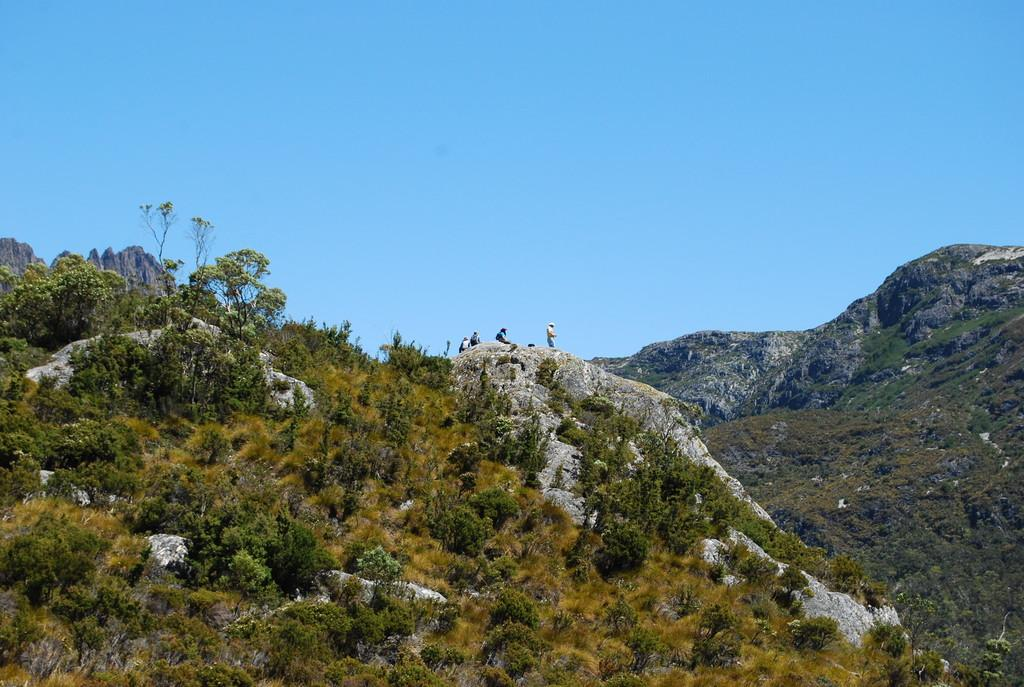What type of natural formation can be seen in the image? There are mountains in the image. What type of vegetation is present in the image? There are trees in the image. Are there any human figures in the image? Yes, there are people standing in the image. What color is the sky in the image? The sky is blue in the image. What word is being used to describe the mass of the mountains in the image? There is no specific word being used to describe the mass of the mountains in the image; the focus is on their presence and appearance. 